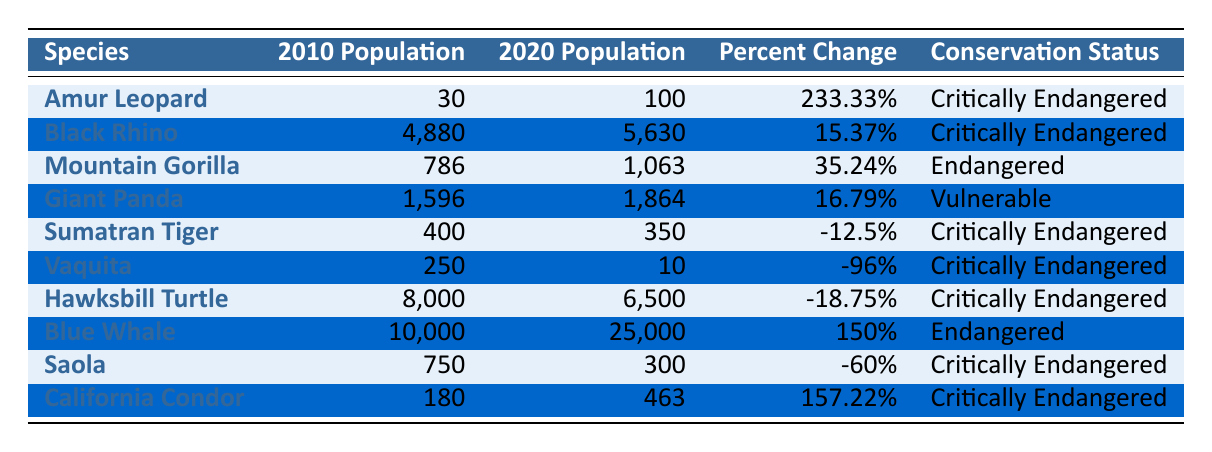What was the population of the Amur Leopard in 2010? The table shows the population of the Amur Leopard for each year. For the year 2010, it states that the population was 30.
Answer: 30 Which species had the highest percent change in population from 2010 to 2020? The percent change is listed for each species. The Amur Leopard had a percent change of 233.33%, which is the highest among all the species listed.
Answer: Amur Leopard Was the population of the Sumatran Tiger higher in 2020 than in 2010? By checking the table, the population of the Sumatran Tiger in 2010 was 400, and in 2020, it was 350. Since 350 is less than 400, the population was not higher.
Answer: No What is the total population for the Blue Whale in 2020 and the California Condor in 2020 added together? The Blue Whale population in 2020 is 25,000, and the California Condor population in 2020 is 463. Adding these together gives 25,000 + 463 = 25,463.
Answer: 25463 Which species experienced a decline in population over the past decade? To identify species with a decline, I will look for negative percent changes. The Sumatran Tiger, Vaquita, Hawksbill Turtle, and Saola all show negative percent changes (-12.5%, -96%, -18.75%, -60%, respectively).
Answer: Sumatran Tiger, Vaquita, Hawksbill Turtle, Saola What is the average population of all species in 2020? The populations in 2020 are: 100, 5630, 1063, 1864, 350, 10, 6500, 25000, 300, and 463. Adding these gives 100 + 5630 + 1063 + 1864 + 350 + 10 + 6500 + 25000 + 300 + 463 = 33480. There are 10 species, so the average is 33480/10 = 3348.
Answer: 3348 Did the Black Rhino's population grow at a rate higher than the Giant Panda's over the last decade? The Black Rhino's percent change is 15.37%, while the Giant Panda's percent change is 16.79%. Since 15.37% is less than 16.79%, the Black Rhino did not grow at a higher rate.
Answer: No What conservation status is shared by the highest number of species in the table? Upon checking the table, the "Critically Endangered" status is listed for multiple species: Amur Leopard, Black Rhino, Sumatran Tiger, Vaquita, Hawksbill Turtle, and Saola. This is a total of six species.
Answer: Critically Endangered 